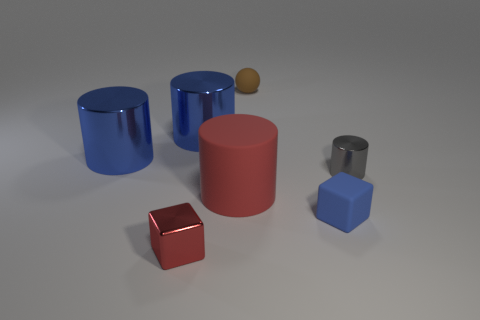How many things are large green rubber blocks or large shiny objects?
Your answer should be compact. 2. What size is the matte object on the right side of the tiny rubber ball?
Give a very brief answer. Small. What is the color of the thing that is in front of the big matte thing and to the left of the red matte object?
Provide a short and direct response. Red. Does the large blue object on the right side of the red metallic thing have the same material as the small blue block?
Give a very brief answer. No. There is a tiny metallic block; does it have the same color as the large cylinder that is in front of the gray shiny cylinder?
Your response must be concise. Yes. Are there any tiny cubes behind the tiny red cube?
Ensure brevity in your answer.  Yes. Is the size of the object on the left side of the red block the same as the cylinder that is in front of the gray metallic cylinder?
Your answer should be compact. Yes. Are there any gray metallic things that have the same size as the blue cube?
Provide a succinct answer. Yes. There is a small metallic object in front of the small gray thing; does it have the same shape as the small blue object?
Give a very brief answer. Yes. What is the material of the block that is in front of the blue matte cube?
Keep it short and to the point. Metal. 